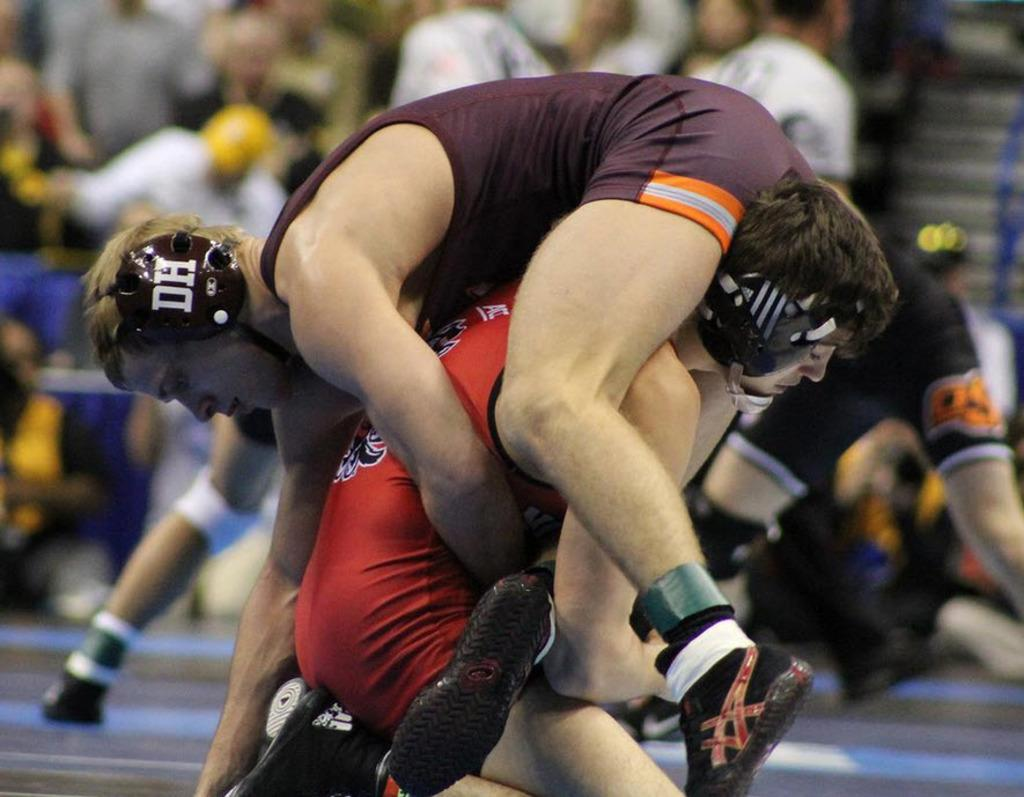<image>
Present a compact description of the photo's key features. the man on top wears a head protection with DH on it 